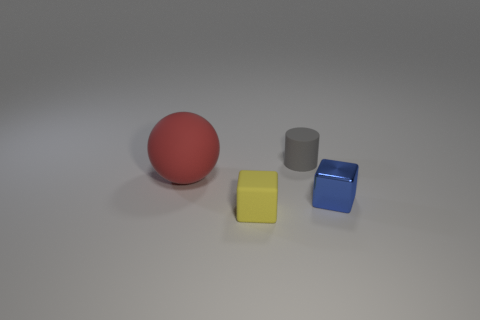There is another object that is the same shape as the yellow matte thing; what color is it?
Offer a very short reply. Blue. There is a rubber cylinder that is the same size as the yellow block; what color is it?
Ensure brevity in your answer.  Gray. Is the material of the small gray thing the same as the sphere?
Offer a terse response. Yes. What number of small rubber cubes are the same color as the shiny thing?
Provide a succinct answer. 0. Do the rubber block and the small rubber cylinder have the same color?
Make the answer very short. No. What is the material of the tiny block to the left of the blue metallic object?
Ensure brevity in your answer.  Rubber. What number of tiny objects are cyan objects or balls?
Make the answer very short. 0. Are there any tiny brown cubes made of the same material as the yellow object?
Ensure brevity in your answer.  No. There is a cube on the left side of the gray cylinder; does it have the same size as the small blue block?
Provide a succinct answer. Yes. There is a cube that is behind the tiny thing to the left of the tiny gray cylinder; is there a red matte sphere on the right side of it?
Your response must be concise. No. 